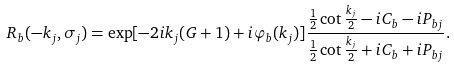<formula> <loc_0><loc_0><loc_500><loc_500>R _ { b } ( - k _ { j } , \sigma _ { j } ) = \exp [ - 2 i k _ { j } ( G + 1 ) + i \varphi _ { b } ( k _ { j } ) ] \frac { \frac { 1 } { 2 } \cot \frac { k _ { j } } 2 - i C _ { b } - i P _ { b j } } { \frac { 1 } { 2 } \cot \frac { k _ { j } } 2 + i C _ { b } + i P _ { b j } } .</formula> 